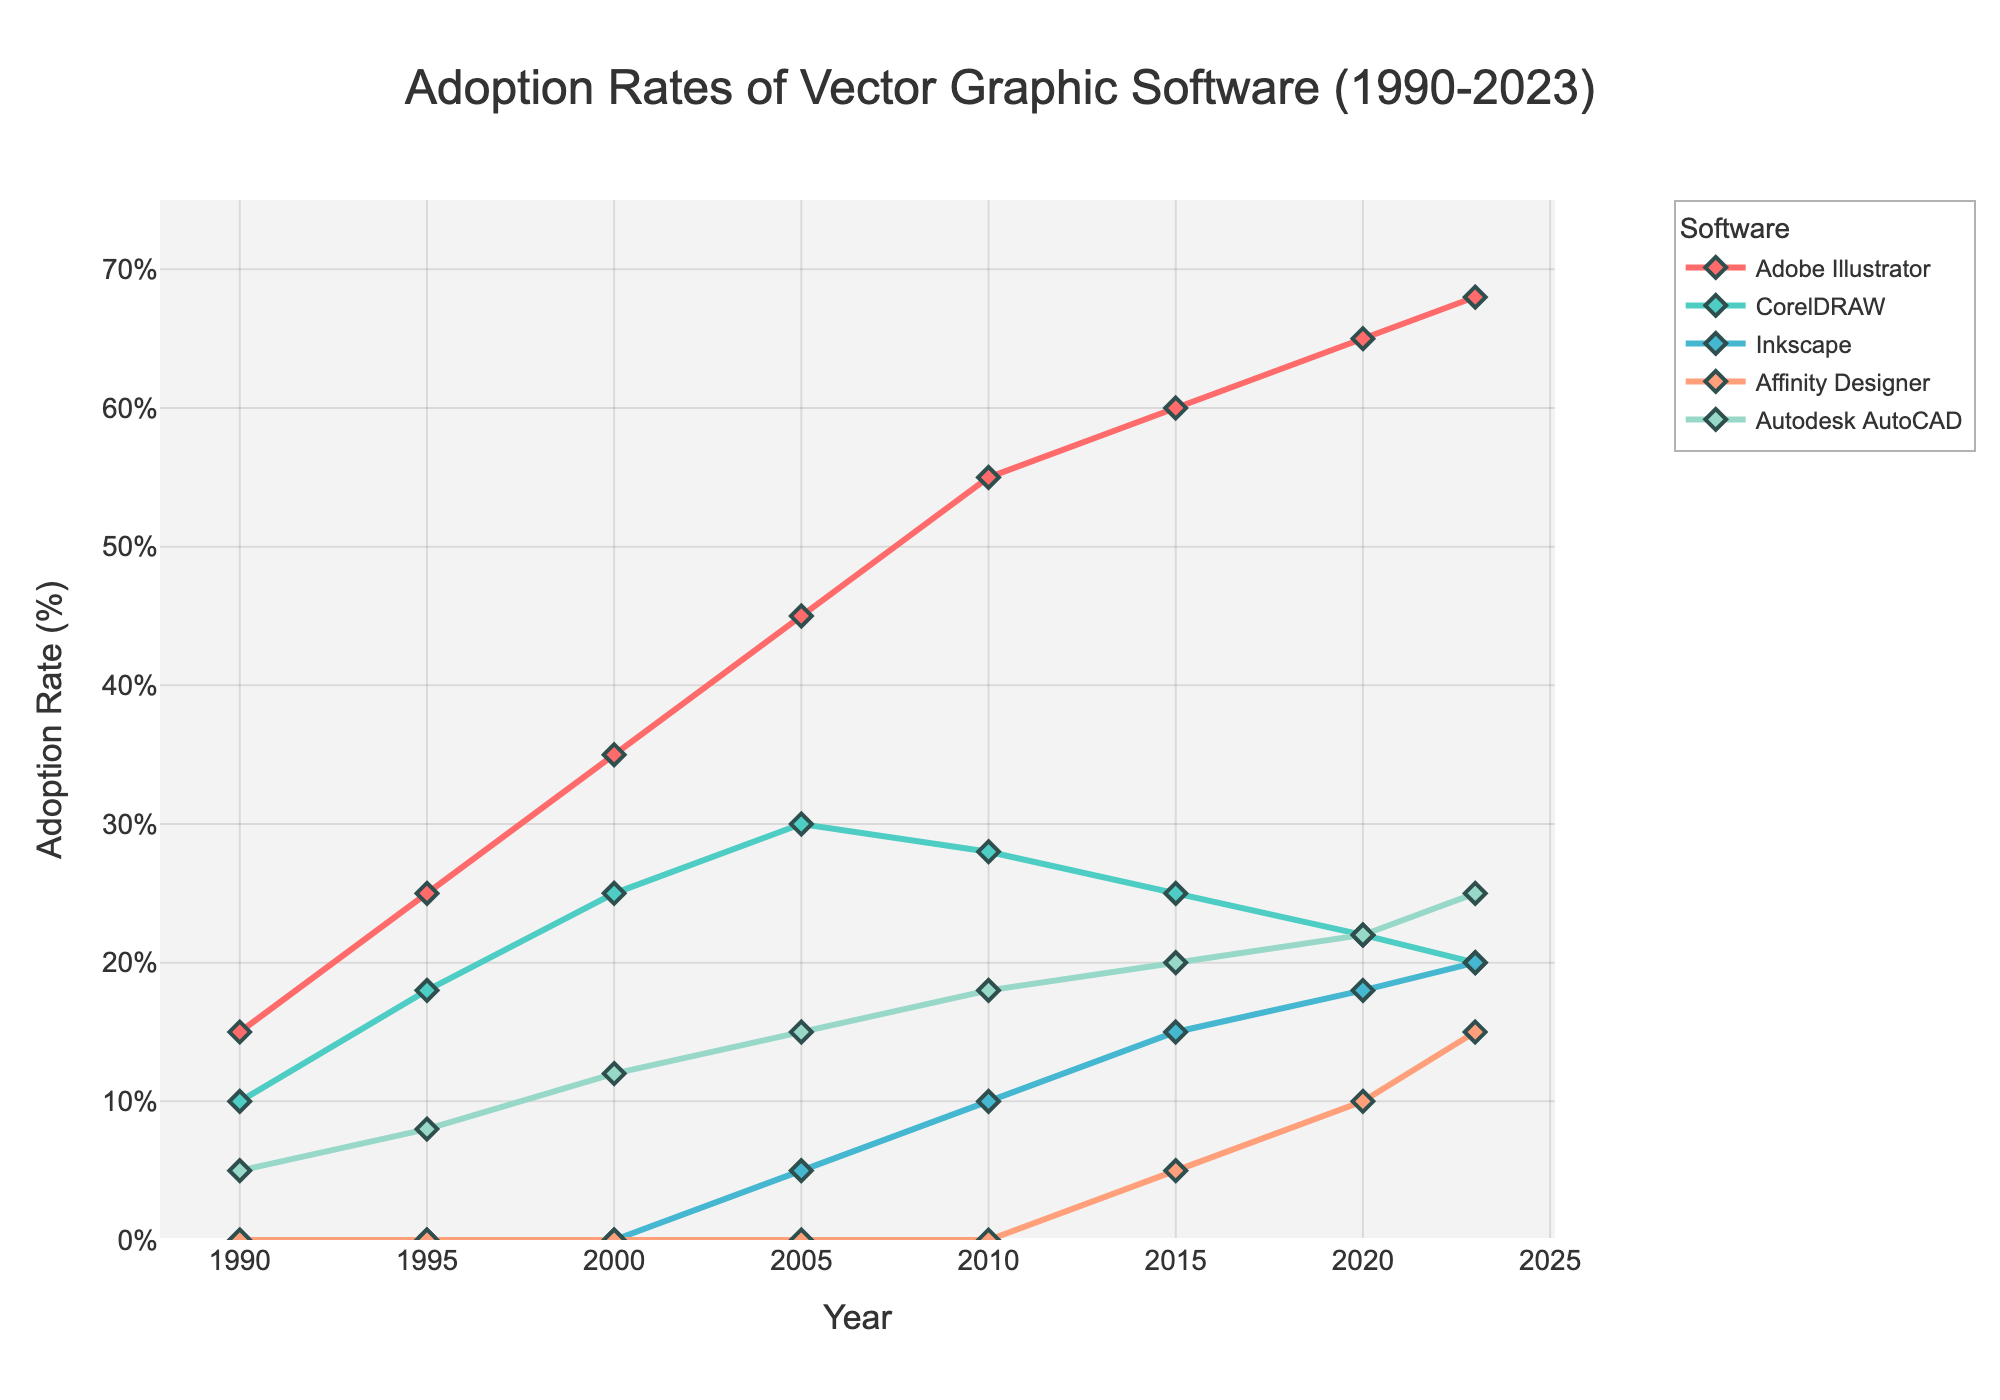What's the adoption rate of Adobe Illustrator in 2023? Look at the 2023 data point for Adobe Illustrator in the legend or the y-axis corresponding to that year.
Answer: 68% Which software had the lowest adoption rate in the year 2010? Compare the adoption rates of each software in 2010 by looking at their respective lines on the chart. Inkscape had the lowest adoption rate.
Answer: Inkscape What is the difference in adoption rates between CorelDRAW and Adobe Illustrator in 2000? Subtract the adoption rate of CorelDRAW from that of Adobe Illustrator in the year 2000. Adobe Illustrator is 35%, and CorelDRAW is 25%. So, 35% - 25% = 10%.
Answer: 10% How did the adoption rate of Affinity Designer change from 2015 to 2023? Look at Affinity Designer's adoption rates in 2015 and 2023 and calculate the difference: 15% (2023) - 5% (2015) = 10%.
Answer: Increased by 10% Which software has shown a consistent increase in adoption rates from 1990 to 2023? Examine each software's adoption rate trend over time. Adobe Illustrator's line consistently increases from 1990 to 2023.
Answer: Adobe Illustrator What is the total adoption rate for Inkscape between 2005 and 2020? Sum the adoption rates of Inkscape for the years 2005, 2010, 2015, and 2020: 5% + 10% + 15% + 18% = 48%.
Answer: 48% Which software had the highest adoption rate in 1995? Compare the adoption rates of all software in 1995. Adobe Illustrator had the highest adoption rate of 25%.
Answer: Adobe Illustrator How does the adoption rate of Autodesk AutoCAD in 2020 compare to its rate in 1990? Compare the adoption rates for Autodesk AutoCAD in 1990 and 2020: 1990 (5%) and 2020 (22%). The adoption rate increased.
Answer: Increased by 17% What is the average adoption rate of CorelDRAW from 1990 to 2023? Calculate the average by summing the adoption rates of CorelDRAW for all years and dividing by the number of years: (10+18+25+30+28+25+22+20)/8 = 23.5%.
Answer: 23.5% Which software showed the greatest increase in adoption rate from 1990 to 2000? Subtract the adoption rates in 1990 from the rates in 2000 for each software and find the maximum difference. Adobe Illustrator: 35% - 15% = 20%. It has the highest increase.
Answer: Adobe Illustrator 